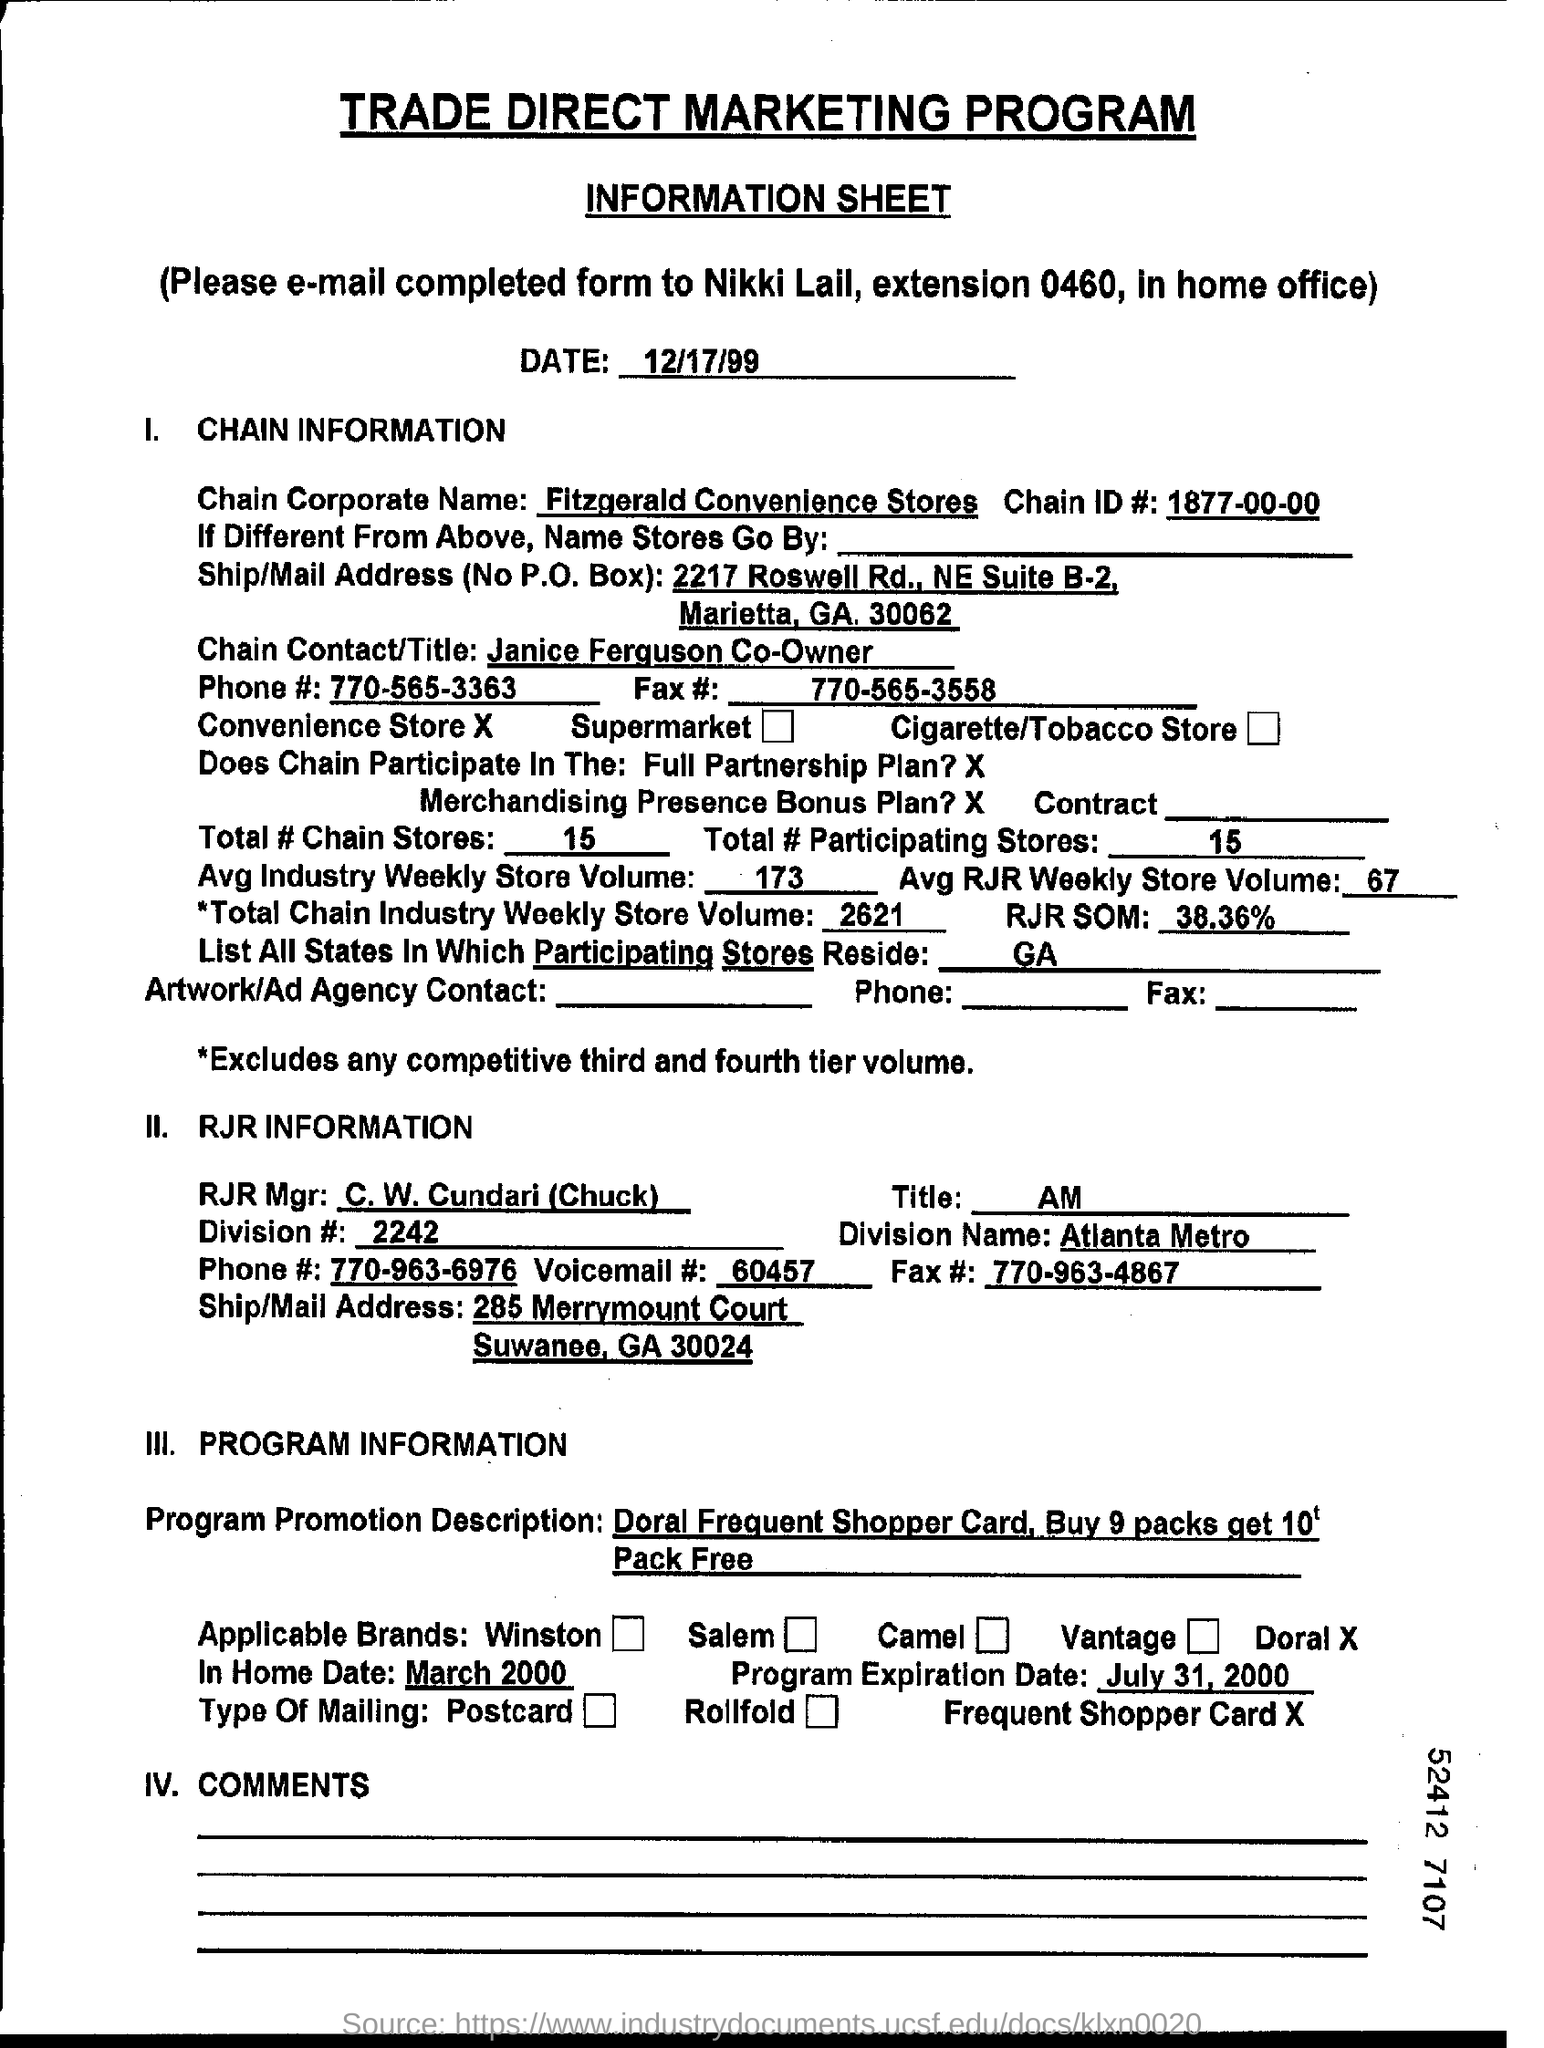What is the Chain Corporate Name given in the document?
Your response must be concise. Fitzgerald convenience stores. What is the Chain ID# as per the document?
Ensure brevity in your answer.  1877-00-00. How many Total Chain stores are there?
Your answer should be compact. 15. What is the Avg RJR Weekly Store Volume?
Make the answer very short. 67. Who is RJR Mgr?
Provide a succinct answer. C. W. Cundari (Chuck). What is the Avg Industry Weekly Store Volume?
Make the answer very short. 173. What is the Program Expiration Date mentioned in the document?
Offer a very short reply. July 31, 2000. 